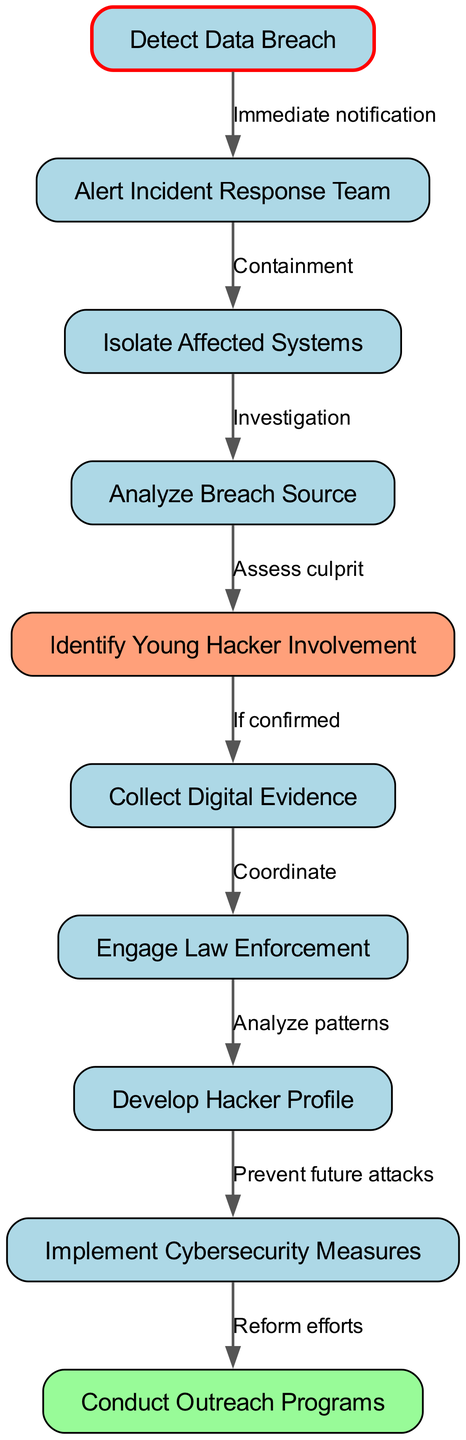What is the first step in the workflow? The first step is represented by the node "Detect Data Breach," which initiates the incident response process. This information is directly visible as the starting node in the flowchart.
Answer: Detect Data Breach How many nodes are there in total? Counting all the nodes shown in the diagram, we find 10 nodes that represent different stages in the incident response workflow. This can be confirmed by reviewing the list of nodes provided.
Answer: 10 What action follows the alerting of the Incident Response Team? After the "Alert Incident Response Team" node, the next action is to "Isolate Affected Systems." This flow can be traced directly from one node to the next as indicated by the connecting edge.
Answer: Isolate Affected Systems What happens if young hacker involvement is confirmed? If young hacker involvement is confirmed, the next step is "Collect Digital Evidence." This conclusion is drawn from following the pathway that connects these two nodes in the flowchart.
Answer: Collect Digital Evidence What is the final outcome of implementing cybersecurity measures? The final outcome after implementing cybersecurity measures is conducting outreach programs, as indicated by the arrows leading from "Implement Cybersecurity Measures" to "Conduct Outreach Programs." This shows the sequential flow of the actions taken in the workflow.
Answer: Conduct Outreach Programs What node indicates the assessment of the culprit? The node that indicates the assessment of the culprit is "Identify Young Hacker Involvement." This node directly leads from the "Analyze Breach Source," showing it as a crucial step to determine hacker involvement.
Answer: Identify Young Hacker Involvement How many edges are there in the workflow? Counting the connections between the nodes, there are a total of 9 edges that represent the relationships and flow of actions taken in response to a data breach.
Answer: 9 What is the purpose of engaging law enforcement in the workflow? Engaging law enforcement comes after collecting digital evidence to coordinate further actions, which indicates the importance of legal intervention in response to a data breach incident.
Answer: Coordinate 